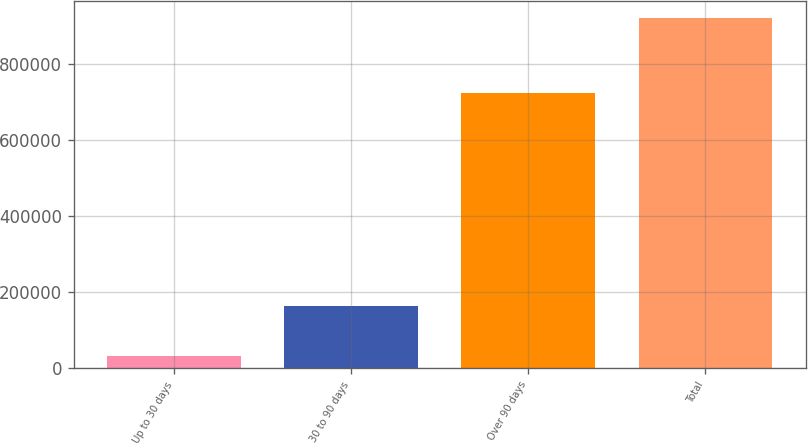Convert chart. <chart><loc_0><loc_0><loc_500><loc_500><bar_chart><fcel>Up to 30 days<fcel>30 to 90 days<fcel>Over 90 days<fcel>Total<nl><fcel>32872<fcel>164358<fcel>723175<fcel>920405<nl></chart> 